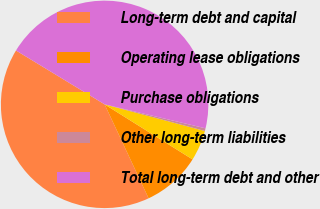Convert chart to OTSL. <chart><loc_0><loc_0><loc_500><loc_500><pie_chart><fcel>Long-term debt and capital<fcel>Operating lease obligations<fcel>Purchase obligations<fcel>Other long-term liabilities<fcel>Total long-term debt and other<nl><fcel>40.66%<fcel>9.13%<fcel>4.77%<fcel>0.42%<fcel>45.02%<nl></chart> 